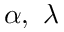Convert formula to latex. <formula><loc_0><loc_0><loc_500><loc_500>\alpha , \lambda</formula> 